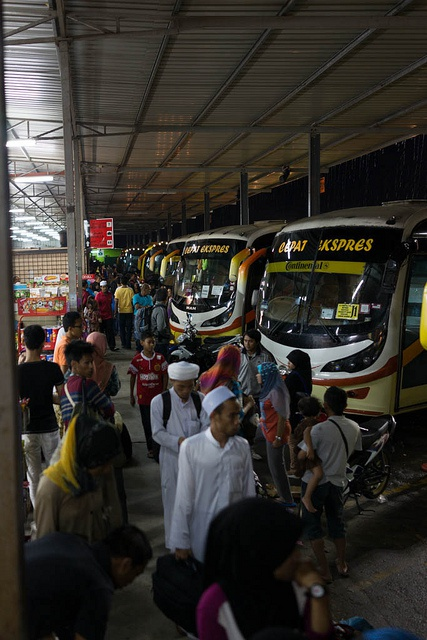Describe the objects in this image and their specific colors. I can see bus in black, gray, olive, and darkgray tones, people in black, gray, and maroon tones, people in black, gray, maroon, and navy tones, people in black, olive, and gray tones, and bus in black, gray, darkgray, and olive tones in this image. 